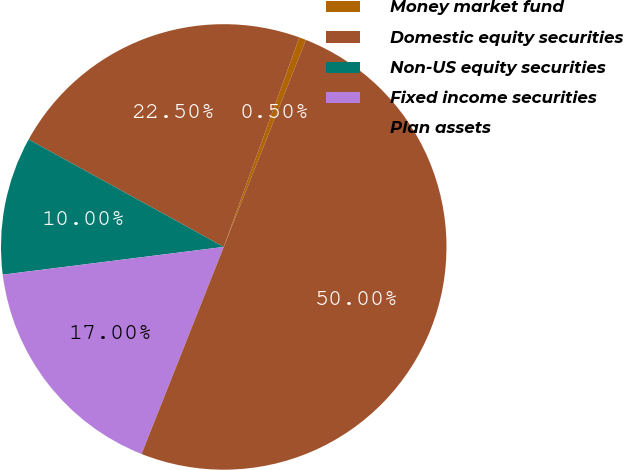<chart> <loc_0><loc_0><loc_500><loc_500><pie_chart><fcel>Money market fund<fcel>Domestic equity securities<fcel>Non-US equity securities<fcel>Fixed income securities<fcel>Plan assets<nl><fcel>0.5%<fcel>22.5%<fcel>10.0%<fcel>17.0%<fcel>50.0%<nl></chart> 